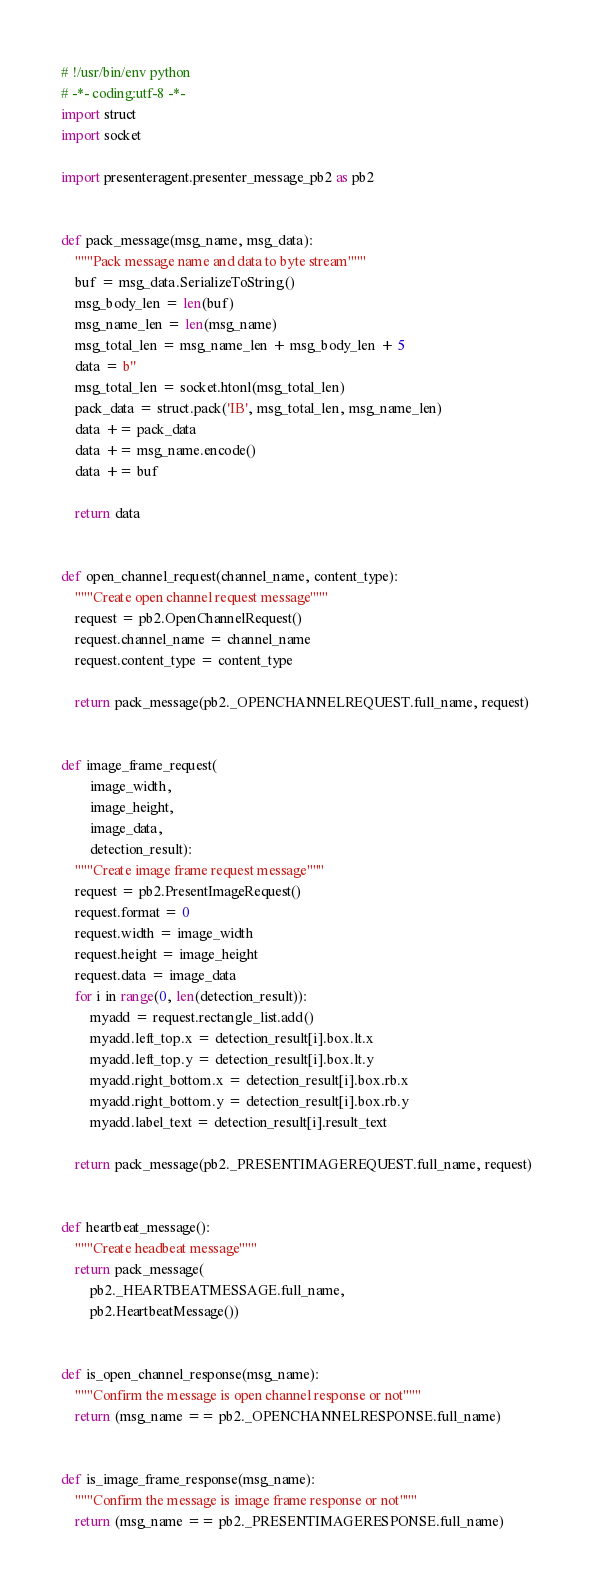Convert code to text. <code><loc_0><loc_0><loc_500><loc_500><_Python_># !/usr/bin/env python
# -*- coding:utf-8 -*-
import struct
import socket

import presenteragent.presenter_message_pb2 as pb2


def pack_message(msg_name, msg_data):
    """Pack message name and data to byte stream"""
    buf = msg_data.SerializeToString()
    msg_body_len = len(buf)
    msg_name_len = len(msg_name)
    msg_total_len = msg_name_len + msg_body_len + 5
    data = b''
    msg_total_len = socket.htonl(msg_total_len)
    pack_data = struct.pack('IB', msg_total_len, msg_name_len)
    data += pack_data
    data += msg_name.encode()
    data += buf

    return data


def open_channel_request(channel_name, content_type):
    """Create open channel request message"""
    request = pb2.OpenChannelRequest()
    request.channel_name = channel_name
    request.content_type = content_type

    return pack_message(pb2._OPENCHANNELREQUEST.full_name, request)


def image_frame_request(
        image_width,
        image_height,
        image_data,
        detection_result):
    """Create image frame request message"""
    request = pb2.PresentImageRequest()
    request.format = 0
    request.width = image_width
    request.height = image_height
    request.data = image_data
    for i in range(0, len(detection_result)):
        myadd = request.rectangle_list.add()
        myadd.left_top.x = detection_result[i].box.lt.x
        myadd.left_top.y = detection_result[i].box.lt.y
        myadd.right_bottom.x = detection_result[i].box.rb.x
        myadd.right_bottom.y = detection_result[i].box.rb.y
        myadd.label_text = detection_result[i].result_text

    return pack_message(pb2._PRESENTIMAGEREQUEST.full_name, request)


def heartbeat_message():
    """Create headbeat message"""
    return pack_message(
        pb2._HEARTBEATMESSAGE.full_name,
        pb2.HeartbeatMessage())


def is_open_channel_response(msg_name):
    """Confirm the message is open channel response or not"""
    return (msg_name == pb2._OPENCHANNELRESPONSE.full_name)


def is_image_frame_response(msg_name):
    """Confirm the message is image frame response or not"""
    return (msg_name == pb2._PRESENTIMAGERESPONSE.full_name)
</code> 